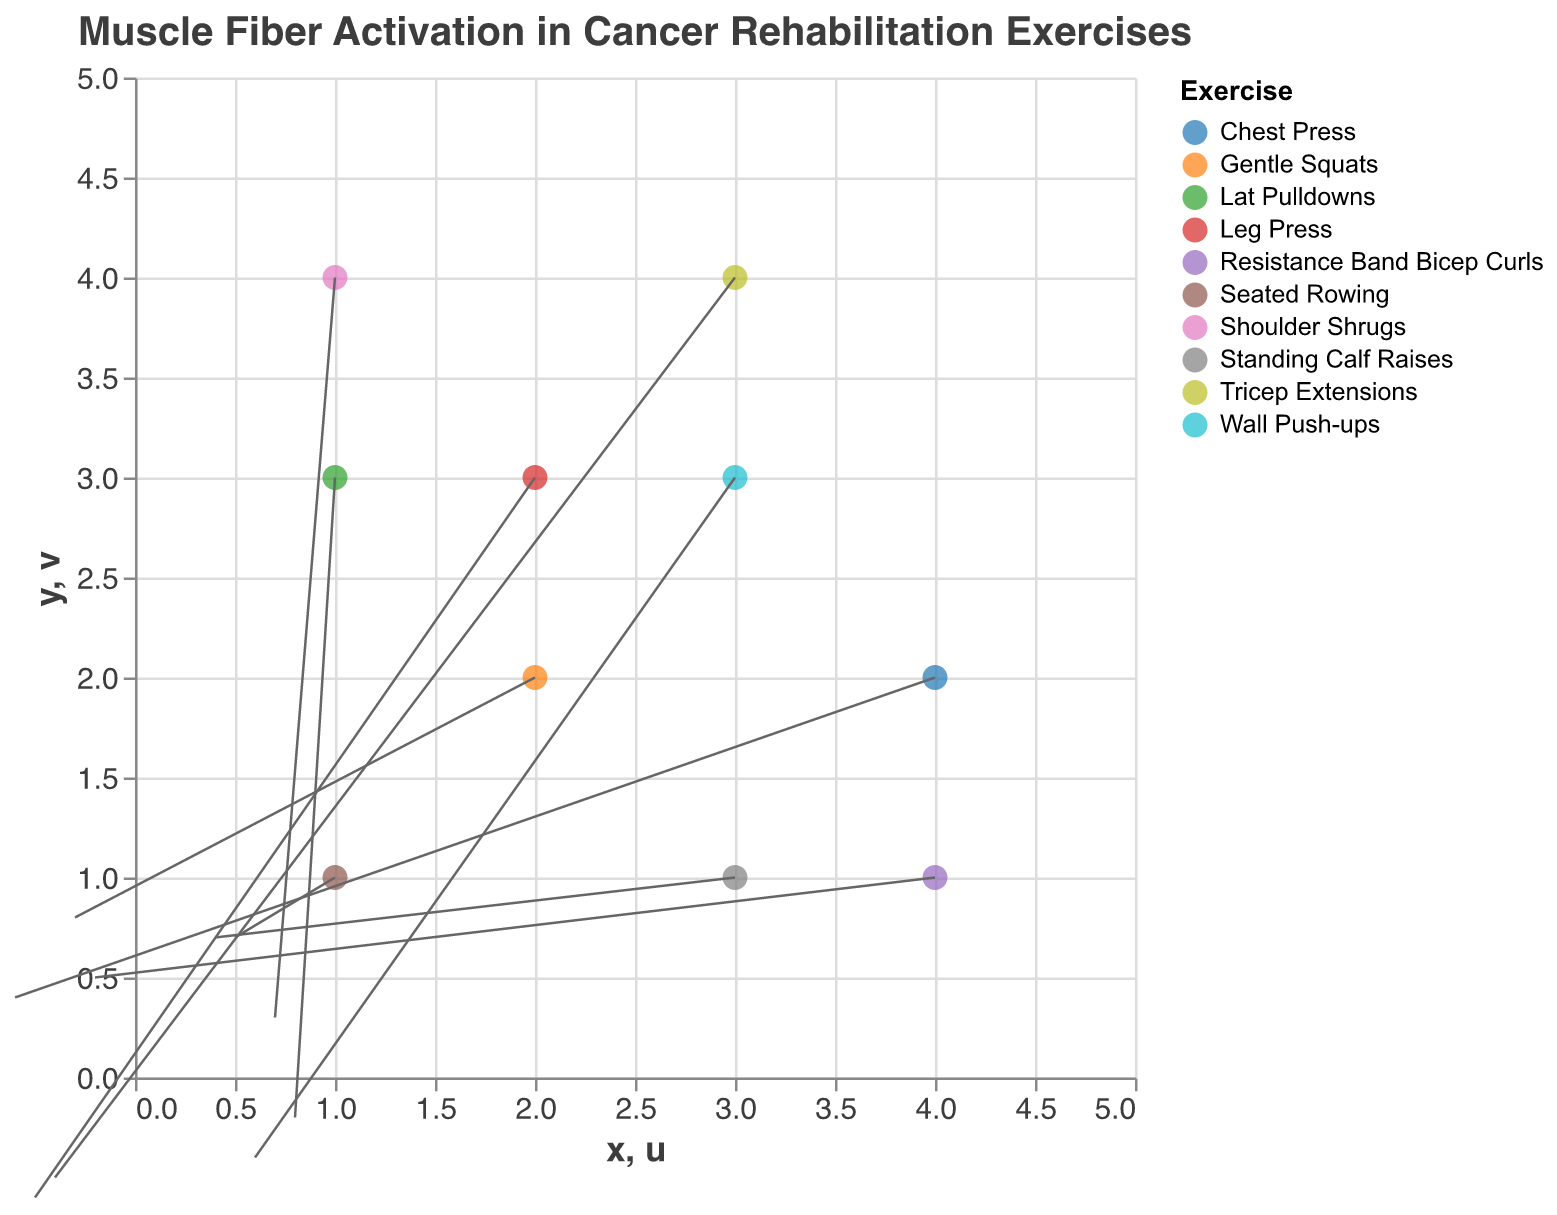What's the title of the plot? The title of the plot is positioned at the top and provides an overview of what the plot is about.
Answer: Muscle Fiber Activation in Cancer Rehabilitation Exercises How many different exercises are depicted in the plot? By looking at the legend to the right of the plot, we can count the number of distinct exercises listed.
Answer: 10 Which exercise shows the largest positive horizontal movement (u)? Examine the label of each vector for its 'u' component and identify the largest positive value.
Answer: Lat Pulldowns What are the coordinates and vectors for "Wall Push-ups"? Find the point labeled "Wall Push-ups" and read off its coordinates (x, y) and vector components (u, v).
Answer: (3, 3), (0.6, -0.4) Which exercise is located at coordinates (2, 2)? Locate the point at coordinates (2, 2) and read off the exercise from the tooltip or legend.
Answer: Gentle Squats Which exercise has the strongest downward vertical movement (most negative v)? Examine the vertical movement (v) of each vector and find the most negative value.
Answer: Leg Press What is the average horizontal movement (u) for all the exercises? Sum up all the horizontal movement (u) values and divide by the number of exercises. (0.5 + (-0.3) + 0.6 + (-0.2) + 0.7 + (-0.5) + 0.4 + (-0.6) + 0.8 + (-0.4) = 1.0; 1.1 / 10 = 0.1)
Answer: 0.1 Which exercise has the shortest vector (combining both u and v components)? Calculate the Euclidean length for each vector using the formula sqrt(u^2 + v^2) and find the smallest one. Shoulder Shrugs: sqrt(0.7^2 + 0.3^2) = 0.76
Answer: Shoulder Shrugs Compare the direction of vectors for "Standing Calf Raises" and "Lat Pulldowns". Are they moving in similar directions? Examine the vector directions of both exercises. Standing Calf Raises (up and right), Lat Pulldowns (slightly rightward).
Answer: No Sum the vertical movements (v) for the exercises located at x=1. Identify the points along x=1 and sum up their v values. (0.7 from Seated Rowing, 0.3 from Shoulder Shrugs, -0.2 from Lat Pulldowns) = 0.8
Answer: 0.8 